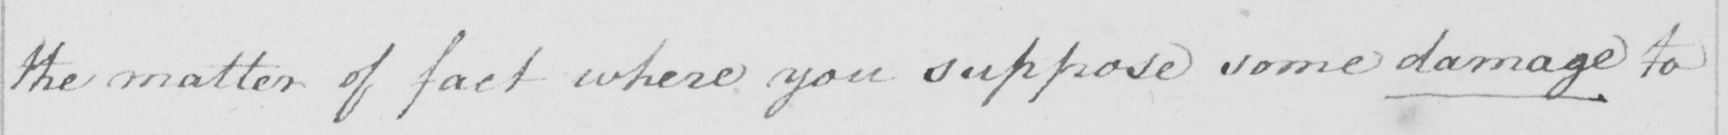What is written in this line of handwriting? the matter of fact where you suppose some damage to 